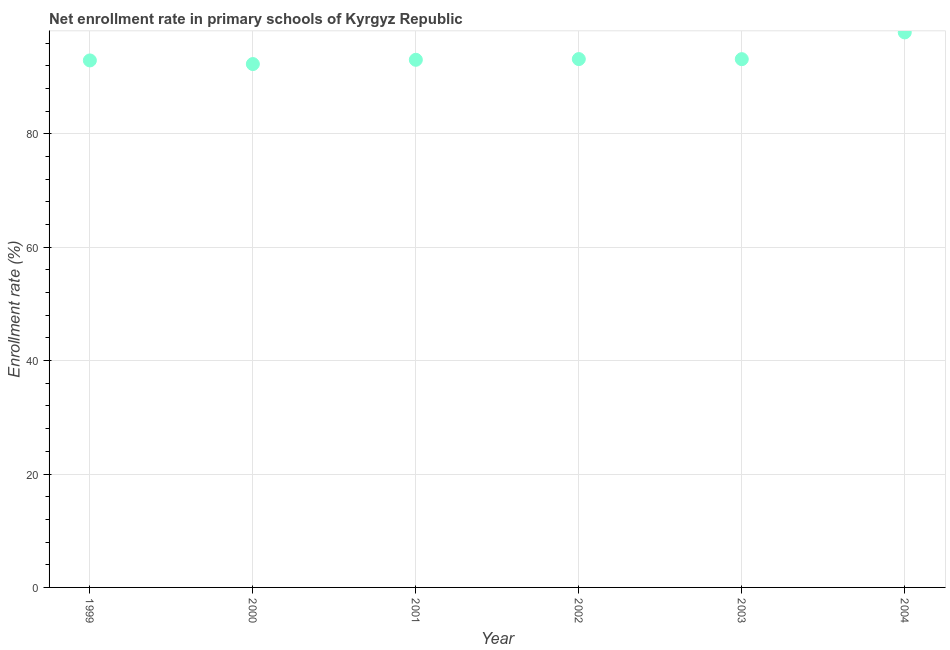What is the net enrollment rate in primary schools in 2003?
Keep it short and to the point. 93.17. Across all years, what is the maximum net enrollment rate in primary schools?
Offer a very short reply. 97.89. Across all years, what is the minimum net enrollment rate in primary schools?
Your answer should be compact. 92.31. What is the sum of the net enrollment rate in primary schools?
Keep it short and to the point. 562.56. What is the difference between the net enrollment rate in primary schools in 1999 and 2000?
Make the answer very short. 0.64. What is the average net enrollment rate in primary schools per year?
Ensure brevity in your answer.  93.76. What is the median net enrollment rate in primary schools?
Make the answer very short. 93.12. Do a majority of the years between 2000 and 2004 (inclusive) have net enrollment rate in primary schools greater than 4 %?
Your answer should be compact. Yes. What is the ratio of the net enrollment rate in primary schools in 1999 to that in 2003?
Keep it short and to the point. 1. What is the difference between the highest and the second highest net enrollment rate in primary schools?
Provide a succinct answer. 4.7. What is the difference between the highest and the lowest net enrollment rate in primary schools?
Provide a succinct answer. 5.58. How many dotlines are there?
Your answer should be compact. 1. Are the values on the major ticks of Y-axis written in scientific E-notation?
Your answer should be compact. No. Does the graph contain any zero values?
Ensure brevity in your answer.  No. Does the graph contain grids?
Your answer should be very brief. Yes. What is the title of the graph?
Offer a terse response. Net enrollment rate in primary schools of Kyrgyz Republic. What is the label or title of the X-axis?
Your answer should be very brief. Year. What is the label or title of the Y-axis?
Provide a short and direct response. Enrollment rate (%). What is the Enrollment rate (%) in 1999?
Give a very brief answer. 92.95. What is the Enrollment rate (%) in 2000?
Offer a terse response. 92.31. What is the Enrollment rate (%) in 2001?
Keep it short and to the point. 93.06. What is the Enrollment rate (%) in 2002?
Give a very brief answer. 93.19. What is the Enrollment rate (%) in 2003?
Make the answer very short. 93.17. What is the Enrollment rate (%) in 2004?
Keep it short and to the point. 97.89. What is the difference between the Enrollment rate (%) in 1999 and 2000?
Ensure brevity in your answer.  0.64. What is the difference between the Enrollment rate (%) in 1999 and 2001?
Make the answer very short. -0.11. What is the difference between the Enrollment rate (%) in 1999 and 2002?
Offer a very short reply. -0.24. What is the difference between the Enrollment rate (%) in 1999 and 2003?
Provide a short and direct response. -0.23. What is the difference between the Enrollment rate (%) in 1999 and 2004?
Make the answer very short. -4.94. What is the difference between the Enrollment rate (%) in 2000 and 2001?
Your response must be concise. -0.75. What is the difference between the Enrollment rate (%) in 2000 and 2002?
Your answer should be very brief. -0.88. What is the difference between the Enrollment rate (%) in 2000 and 2003?
Make the answer very short. -0.86. What is the difference between the Enrollment rate (%) in 2000 and 2004?
Give a very brief answer. -5.58. What is the difference between the Enrollment rate (%) in 2001 and 2002?
Provide a succinct answer. -0.13. What is the difference between the Enrollment rate (%) in 2001 and 2003?
Offer a very short reply. -0.11. What is the difference between the Enrollment rate (%) in 2001 and 2004?
Provide a short and direct response. -4.83. What is the difference between the Enrollment rate (%) in 2002 and 2003?
Ensure brevity in your answer.  0.01. What is the difference between the Enrollment rate (%) in 2002 and 2004?
Offer a very short reply. -4.7. What is the difference between the Enrollment rate (%) in 2003 and 2004?
Your response must be concise. -4.72. What is the ratio of the Enrollment rate (%) in 1999 to that in 2001?
Offer a terse response. 1. What is the ratio of the Enrollment rate (%) in 1999 to that in 2002?
Offer a very short reply. 1. What is the ratio of the Enrollment rate (%) in 1999 to that in 2004?
Keep it short and to the point. 0.95. What is the ratio of the Enrollment rate (%) in 2000 to that in 2001?
Provide a succinct answer. 0.99. What is the ratio of the Enrollment rate (%) in 2000 to that in 2004?
Make the answer very short. 0.94. What is the ratio of the Enrollment rate (%) in 2001 to that in 2004?
Your answer should be very brief. 0.95. What is the ratio of the Enrollment rate (%) in 2002 to that in 2003?
Give a very brief answer. 1. 